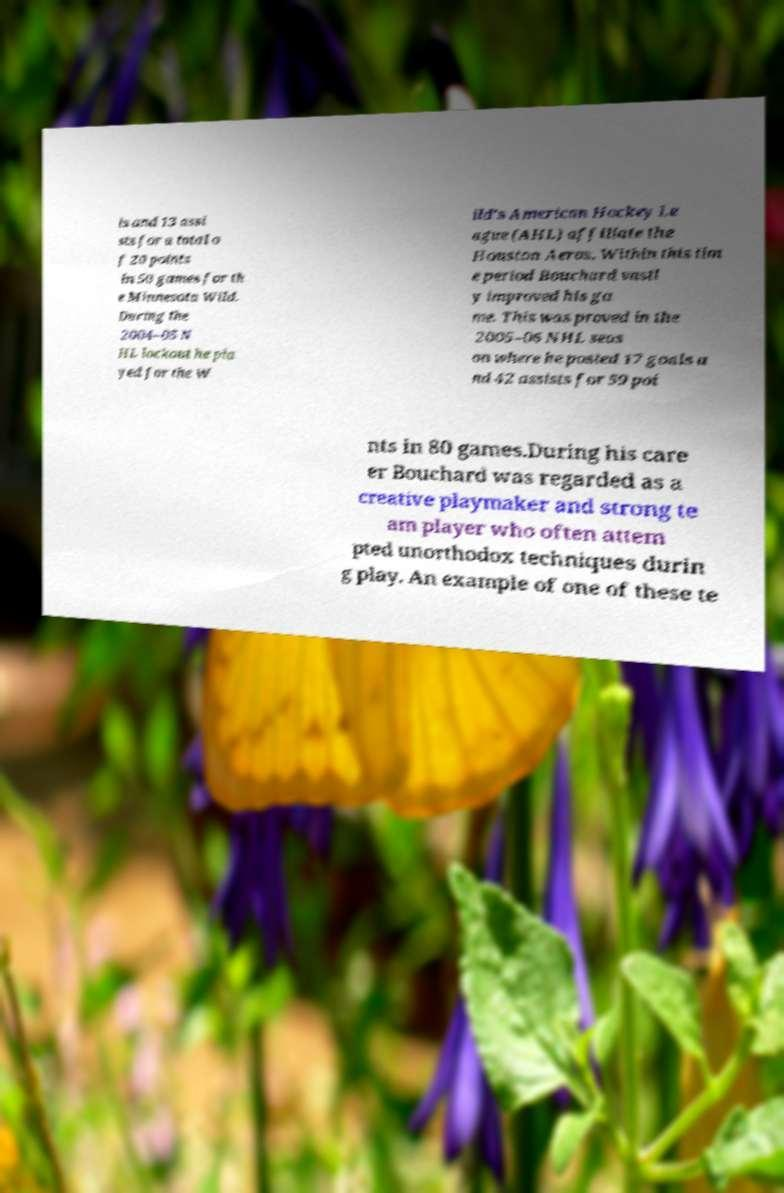I need the written content from this picture converted into text. Can you do that? ls and 13 assi sts for a total o f 20 points in 50 games for th e Minnesota Wild. During the 2004–05 N HL lockout he pla yed for the W ild's American Hockey Le ague (AHL) affiliate the Houston Aeros. Within this tim e period Bouchard vastl y improved his ga me. This was proved in the 2005–06 NHL seas on where he posted 17 goals a nd 42 assists for 59 poi nts in 80 games.During his care er Bouchard was regarded as a creative playmaker and strong te am player who often attem pted unorthodox techniques durin g play. An example of one of these te 